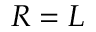<formula> <loc_0><loc_0><loc_500><loc_500>R = L</formula> 